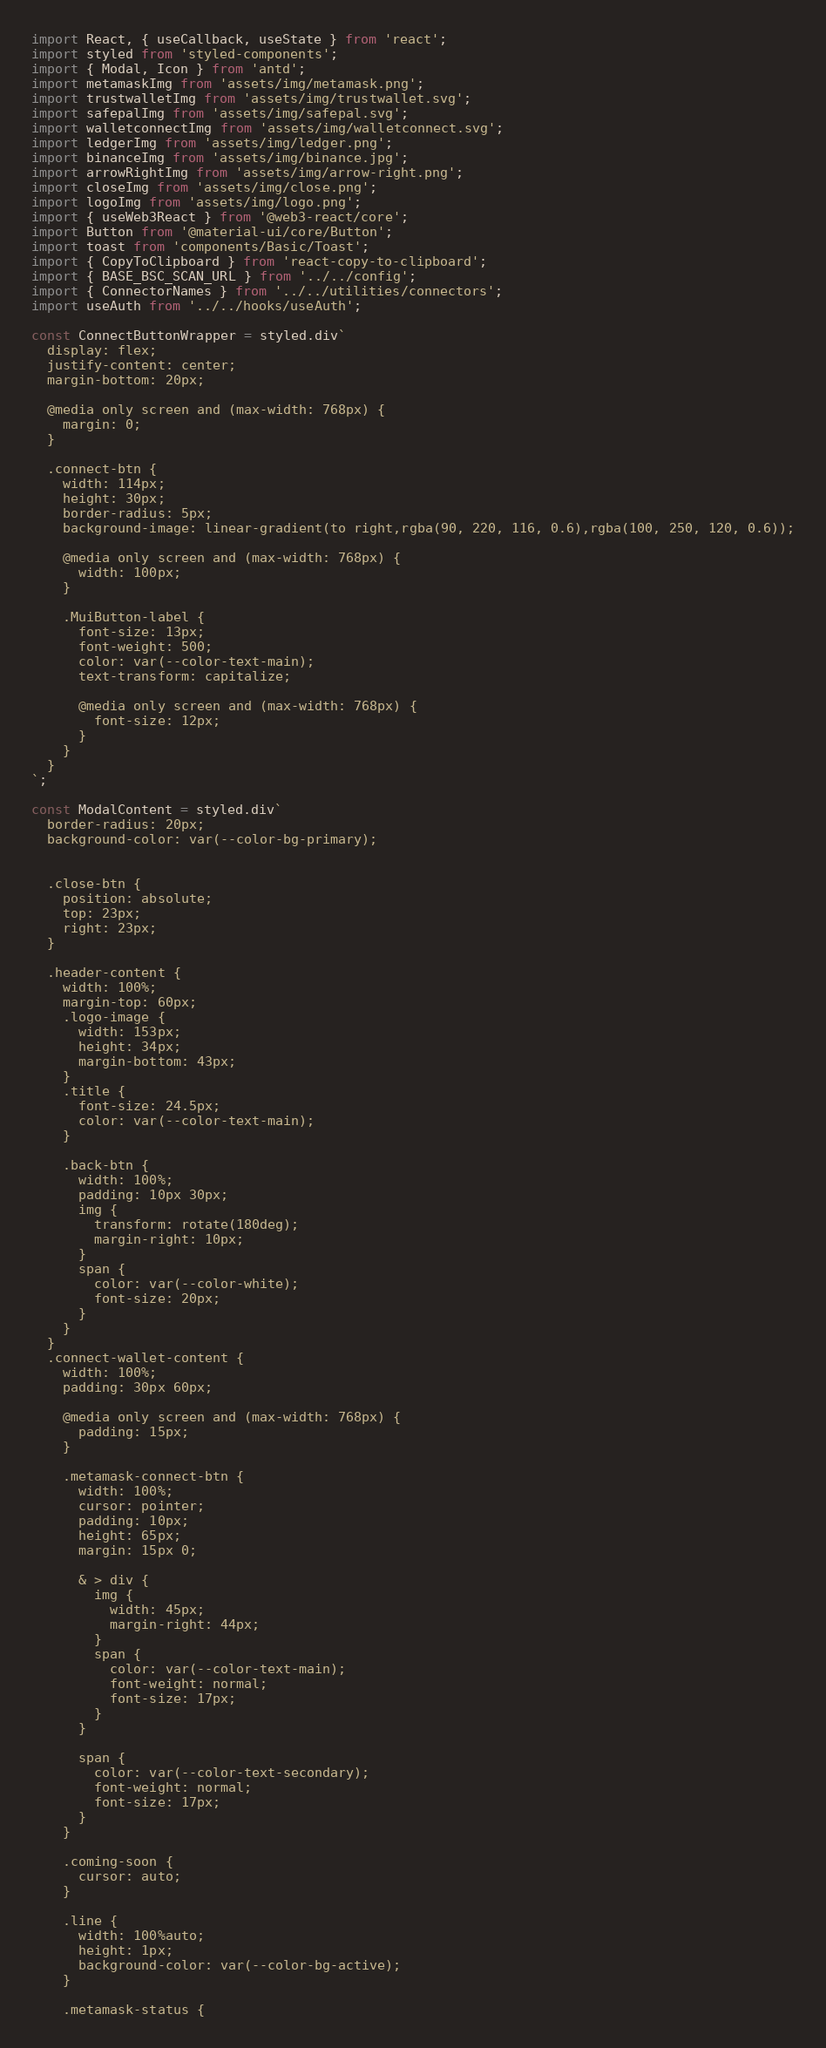Convert code to text. <code><loc_0><loc_0><loc_500><loc_500><_JavaScript_>import React, { useCallback, useState } from 'react';
import styled from 'styled-components';
import { Modal, Icon } from 'antd';
import metamaskImg from 'assets/img/metamask.png';
import trustwalletImg from 'assets/img/trustwallet.svg';
import safepalImg from 'assets/img/safepal.svg';
import walletconnectImg from 'assets/img/walletconnect.svg';
import ledgerImg from 'assets/img/ledger.png';
import binanceImg from 'assets/img/binance.jpg';
import arrowRightImg from 'assets/img/arrow-right.png';
import closeImg from 'assets/img/close.png';
import logoImg from 'assets/img/logo.png';
import { useWeb3React } from '@web3-react/core';
import Button from '@material-ui/core/Button';
import toast from 'components/Basic/Toast';
import { CopyToClipboard } from 'react-copy-to-clipboard';
import { BASE_BSC_SCAN_URL } from '../../config';
import { ConnectorNames } from '../../utilities/connectors';
import useAuth from '../../hooks/useAuth';

const ConnectButtonWrapper = styled.div`
  display: flex;
  justify-content: center;
  margin-bottom: 20px;

  @media only screen and (max-width: 768px) {
    margin: 0;
  }

  .connect-btn {
    width: 114px;
    height: 30px;
    border-radius: 5px;
    background-image: linear-gradient(to right,rgba(90, 220, 116, 0.6),rgba(100, 250, 120, 0.6));

    @media only screen and (max-width: 768px) {
      width: 100px;
    }

    .MuiButton-label {
      font-size: 13px;
      font-weight: 500;
      color: var(--color-text-main);
      text-transform: capitalize;

      @media only screen and (max-width: 768px) {
        font-size: 12px;
      }
    }
  }
`;

const ModalContent = styled.div`
  border-radius: 20px;
  background-color: var(--color-bg-primary);


  .close-btn {
    position: absolute;
    top: 23px;
    right: 23px;
  }

  .header-content {
    width: 100%;
    margin-top: 60px;
    .logo-image {
      width: 153px;
      height: 34px;
      margin-bottom: 43px;
    }
    .title {
      font-size: 24.5px;
      color: var(--color-text-main);
    }

    .back-btn {
      width: 100%;
      padding: 10px 30px;
      img {
        transform: rotate(180deg);
        margin-right: 10px;
      }
      span {
        color: var(--color-white);
        font-size: 20px;
      }
    }
  }
  .connect-wallet-content {
    width: 100%;
    padding: 30px 60px;

    @media only screen and (max-width: 768px) {
      padding: 15px;
    }

    .metamask-connect-btn {
      width: 100%;
      cursor: pointer;
      padding: 10px;
      height: 65px;
      margin: 15px 0;

      & > div {
        img {
          width: 45px;
          margin-right: 44px;
        }
        span {
          color: var(--color-text-main);
          font-weight: normal;
          font-size: 17px;
        }
      }

      span {
        color: var(--color-text-secondary);
        font-weight: normal;
        font-size: 17px;
      }
    }

    .coming-soon {
      cursor: auto;
    }

    .line {
      width: 100%auto;
      height: 1px;
      background-color: var(--color-bg-active);
    }

    .metamask-status {</code> 